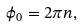<formula> <loc_0><loc_0><loc_500><loc_500>\phi _ { 0 } = 2 \pi n ,</formula> 